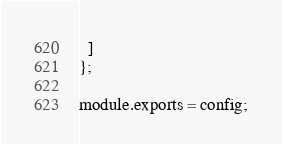Convert code to text. <code><loc_0><loc_0><loc_500><loc_500><_JavaScript_>  ]
};

module.exports = config;
</code> 